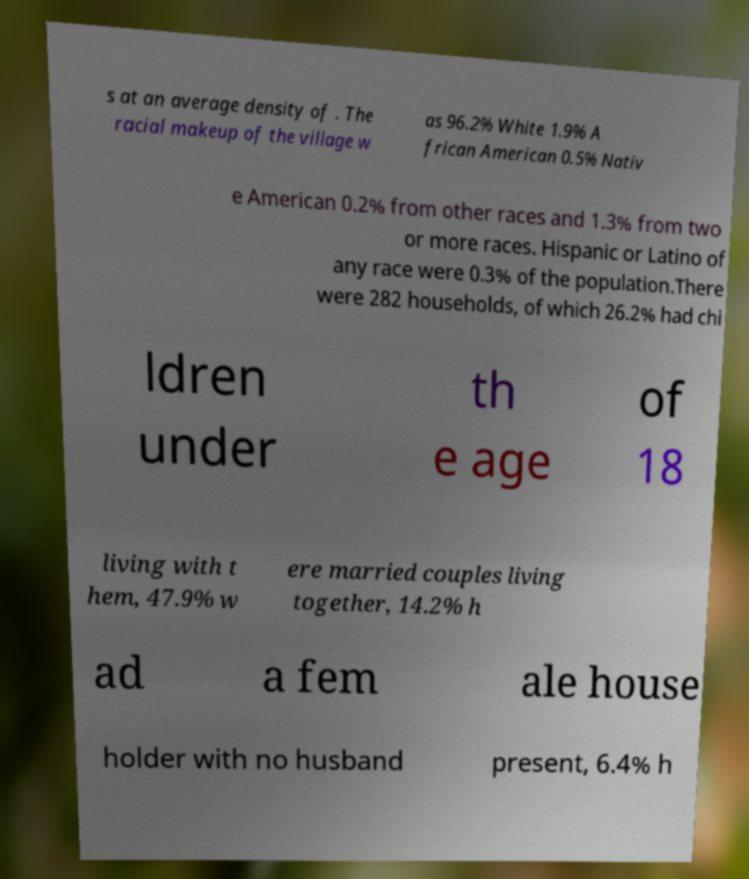Can you read and provide the text displayed in the image?This photo seems to have some interesting text. Can you extract and type it out for me? s at an average density of . The racial makeup of the village w as 96.2% White 1.9% A frican American 0.5% Nativ e American 0.2% from other races and 1.3% from two or more races. Hispanic or Latino of any race were 0.3% of the population.There were 282 households, of which 26.2% had chi ldren under th e age of 18 living with t hem, 47.9% w ere married couples living together, 14.2% h ad a fem ale house holder with no husband present, 6.4% h 